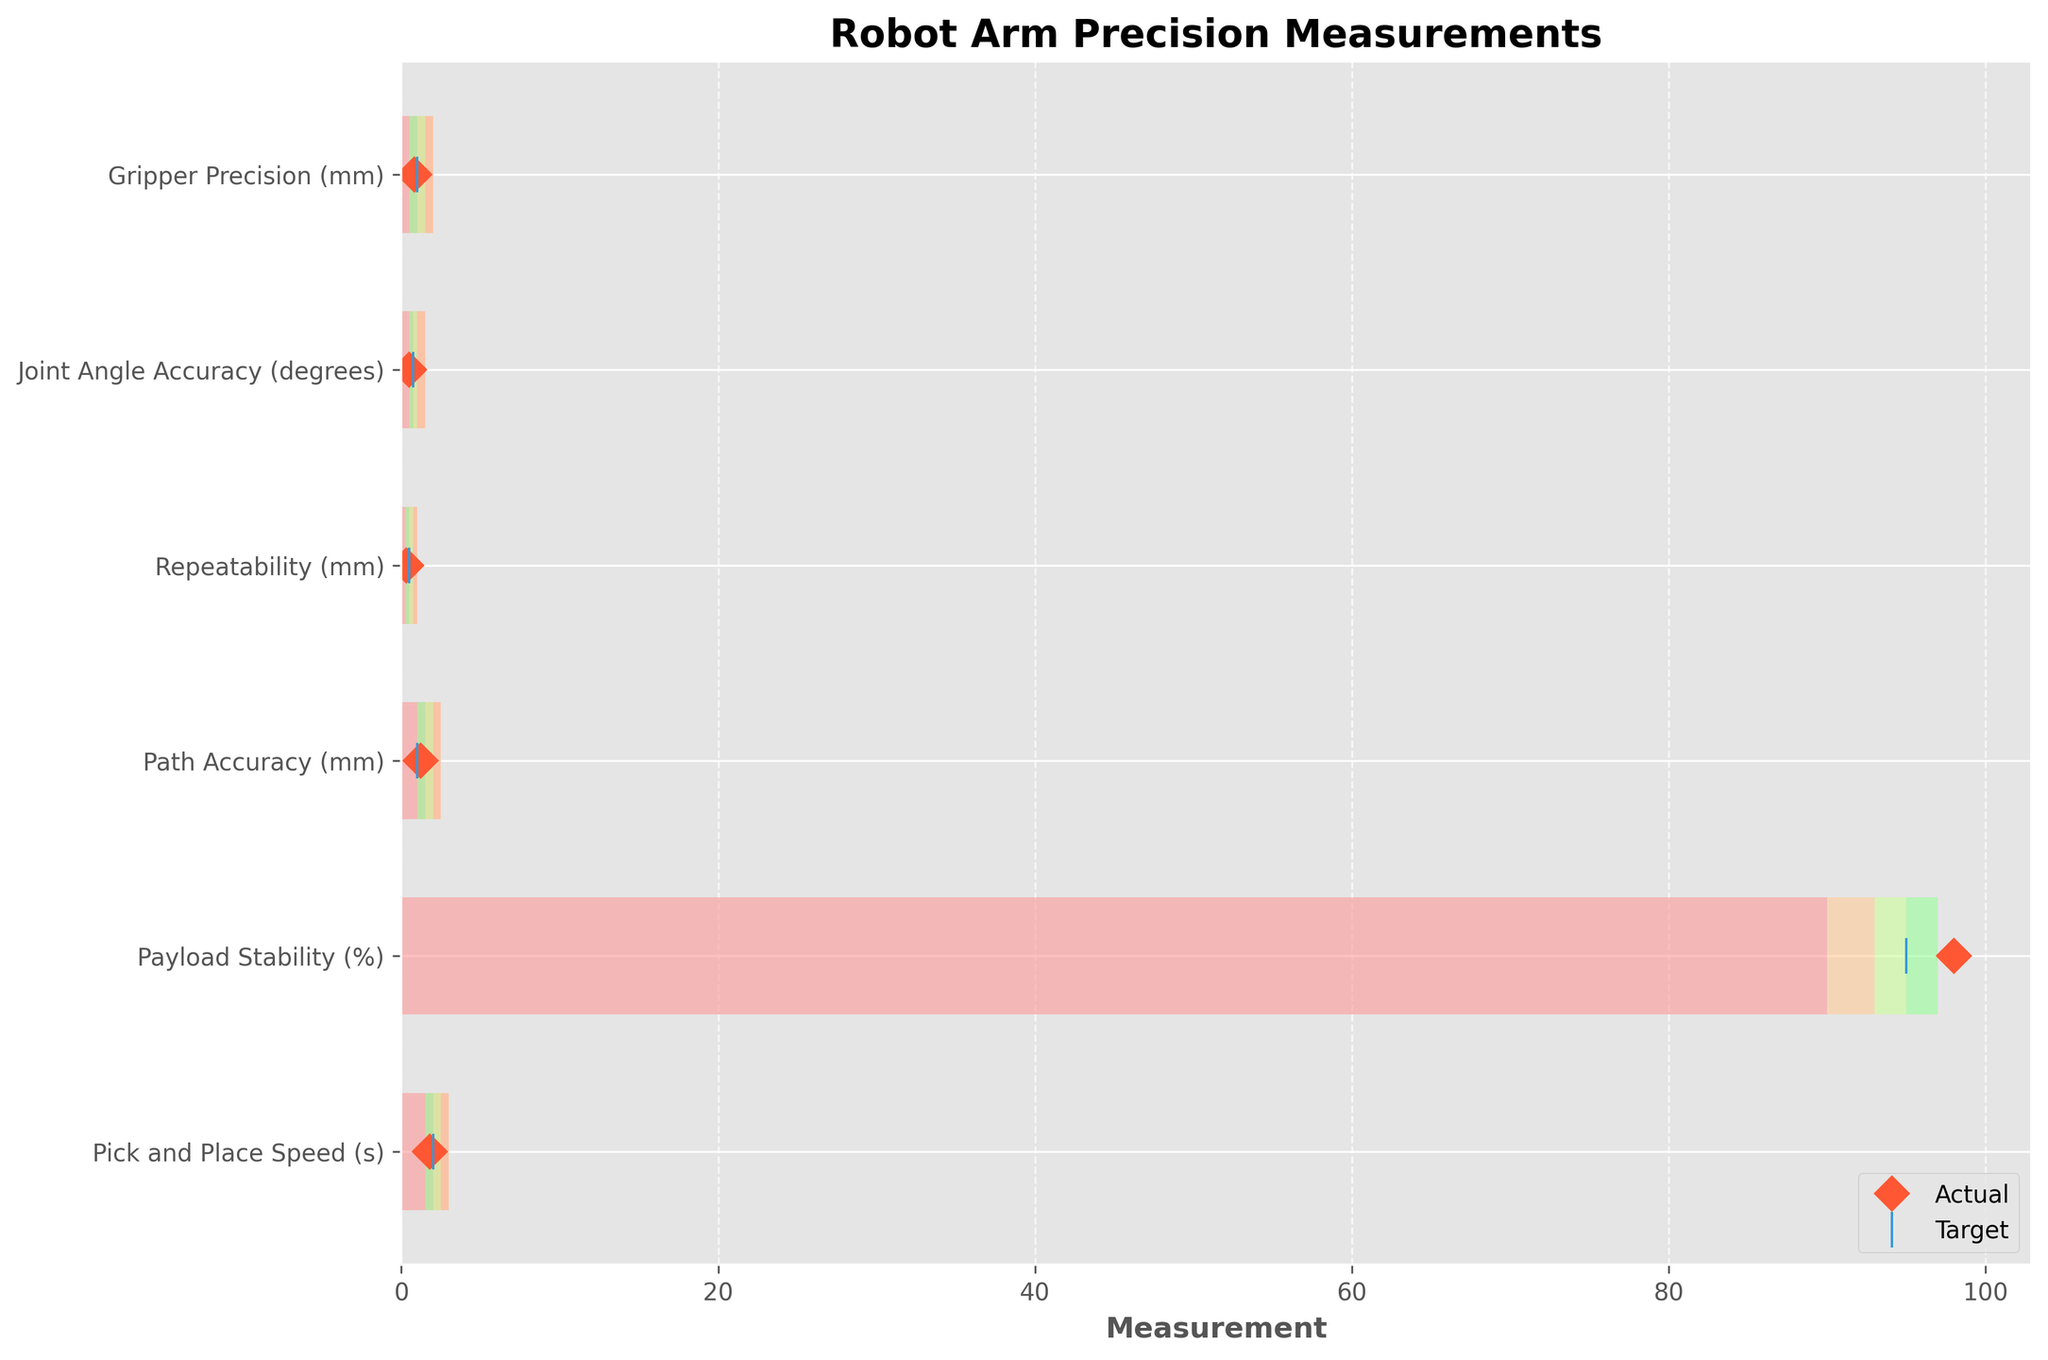what is the title of the plot? The title of the plot is typically placed above the main graph area and summarizes the content of the visualization. Since it is clearly labeled on the figure, we can easily find it there.
Answer: Robot Arm Precision Measurements What is the actual gripper precision in millimeters? The "Actual" values are indicated by orange diamond markers on the plot. Locate the Gripper Precision from the yticks and find the corresponding value.
Answer: 0.8mm Between joint angle accuracy and repeatability, which has a higher actual value? Compare the "Actual" values marked by orange diamonds for both categories. Repeatability shows an actual value of 0.3 degrees, while joint angle accuracy shows 0.5 degrees.
Answer: Joint Angle Accuracy What’s the difference between the actual value and the target value for pick and place speed? To find the difference, we subtract the "Target" value from the "Actual" value. For pick and place speed, the Actual is 1.8 seconds and the Target is 2 seconds. So, 1.8 - 2.0 = -0.2
Answer: -0.2s Which category has all its colored range segments (Poor to Excellent) increasing consecutively? Analyzing each category, we can see that Pick and Place Speed has all its segments increase consistently starting from 3 seconds (Poor) to 1.5 seconds (Excellent).
Answer: Pick and Place Speed In which precision aspect does the actual performance surpass the target? Identify where the actual values, marked by orange diamonds, are less than the respective target values due to lower values indicating better precision in all categories except Payload Stability where a higher value is better. For Payload Stability, the Actual is 98% and the Target is 95%.
Answer: Payload Stability What are the units used for repeatability? The units are indicated in the yticks labels next to each precision aspect. Repeatability is listed as "mm".
Answer: mm Based on the plot, which category falls into the ‘Excellent’ range? Check the Actual values marked by orange diamonds and find which falls within the green section representing "Excellent". Only Payload Stability with an actual value of 98% does.
Answer: Payload Stability 